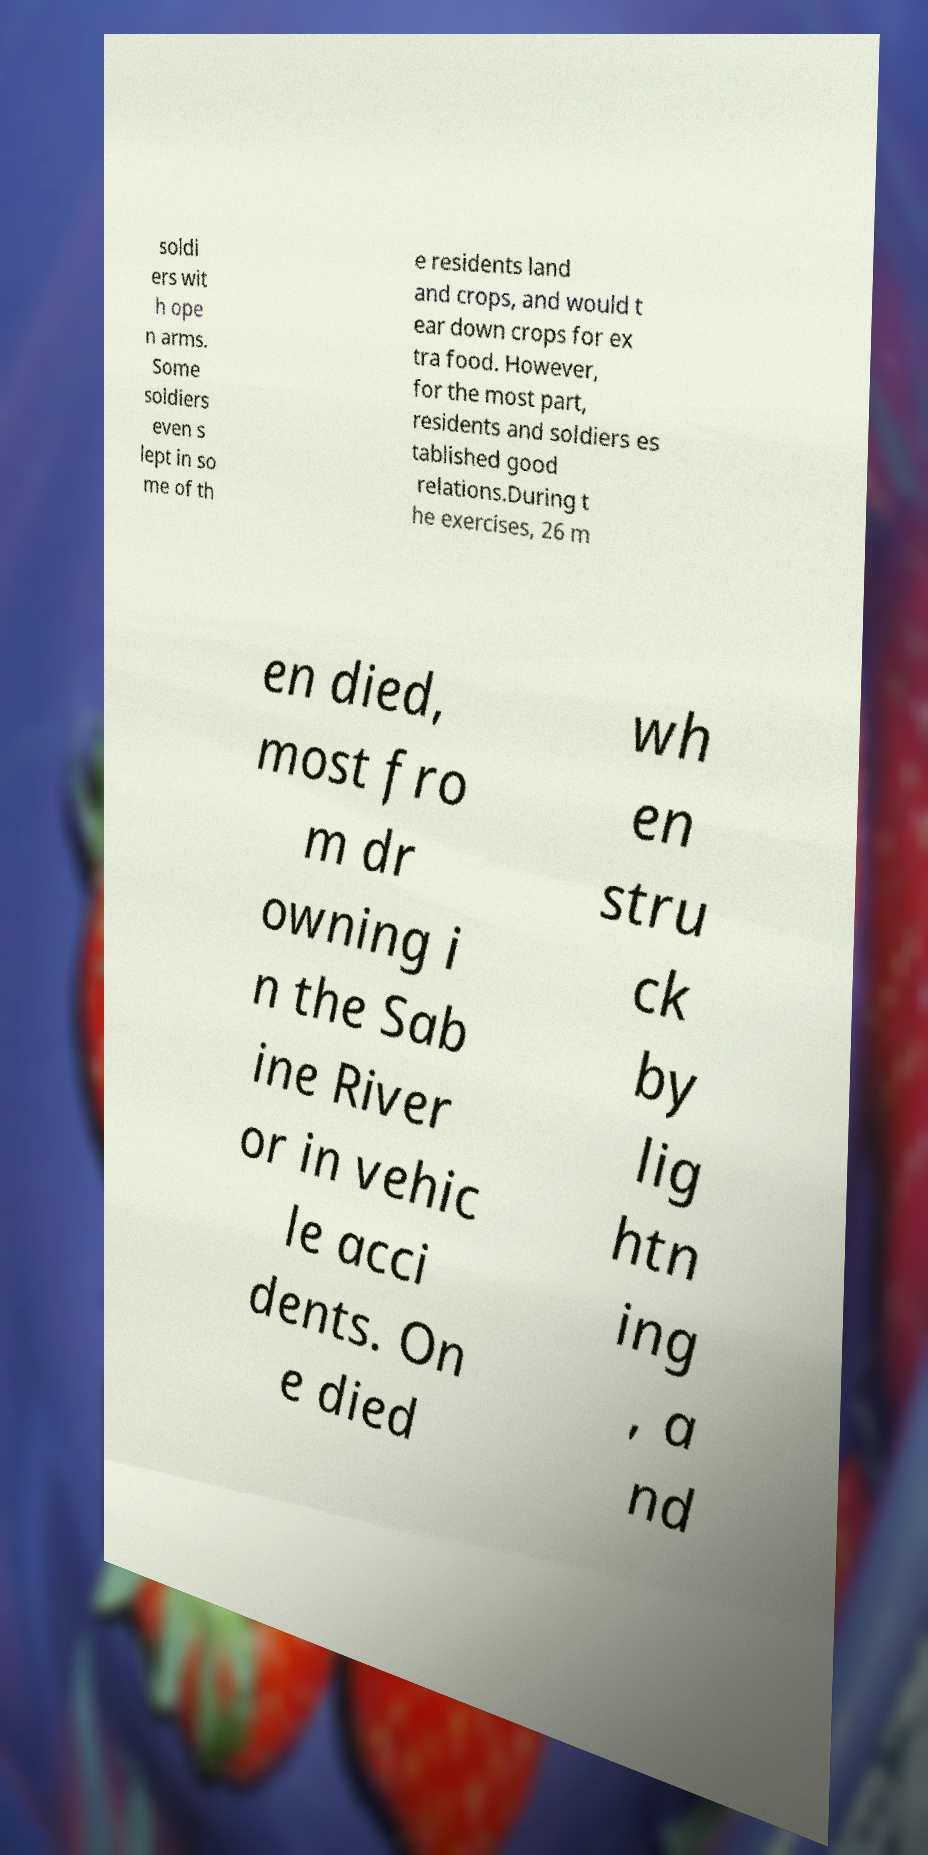Could you extract and type out the text from this image? soldi ers wit h ope n arms. Some soldiers even s lept in so me of th e residents land and crops, and would t ear down crops for ex tra food. However, for the most part, residents and soldiers es tablished good relations.During t he exercises, 26 m en died, most fro m dr owning i n the Sab ine River or in vehic le acci dents. On e died wh en stru ck by lig htn ing , a nd 